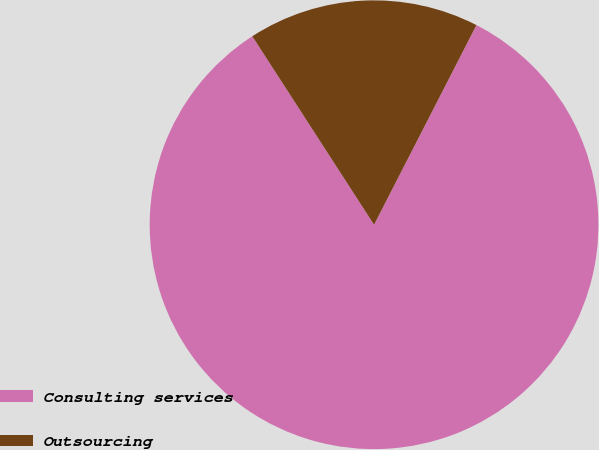Convert chart to OTSL. <chart><loc_0><loc_0><loc_500><loc_500><pie_chart><fcel>Consulting services<fcel>Outsourcing<nl><fcel>83.33%<fcel>16.67%<nl></chart> 